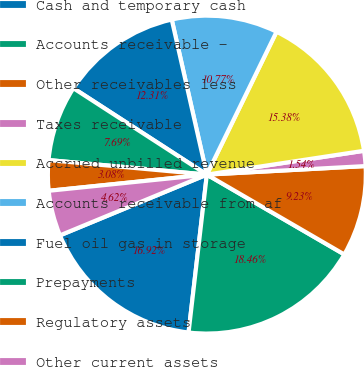Convert chart to OTSL. <chart><loc_0><loc_0><loc_500><loc_500><pie_chart><fcel>Cash and temporary cash<fcel>Accounts receivable -<fcel>Other receivables less<fcel>Taxes receivable<fcel>Accrued unbilled revenue<fcel>Accounts receivable from af<fcel>Fuel oil gas in storage<fcel>Prepayments<fcel>Regulatory assets<fcel>Other current assets<nl><fcel>16.92%<fcel>18.46%<fcel>9.23%<fcel>1.54%<fcel>15.38%<fcel>10.77%<fcel>12.31%<fcel>7.69%<fcel>3.08%<fcel>4.62%<nl></chart> 